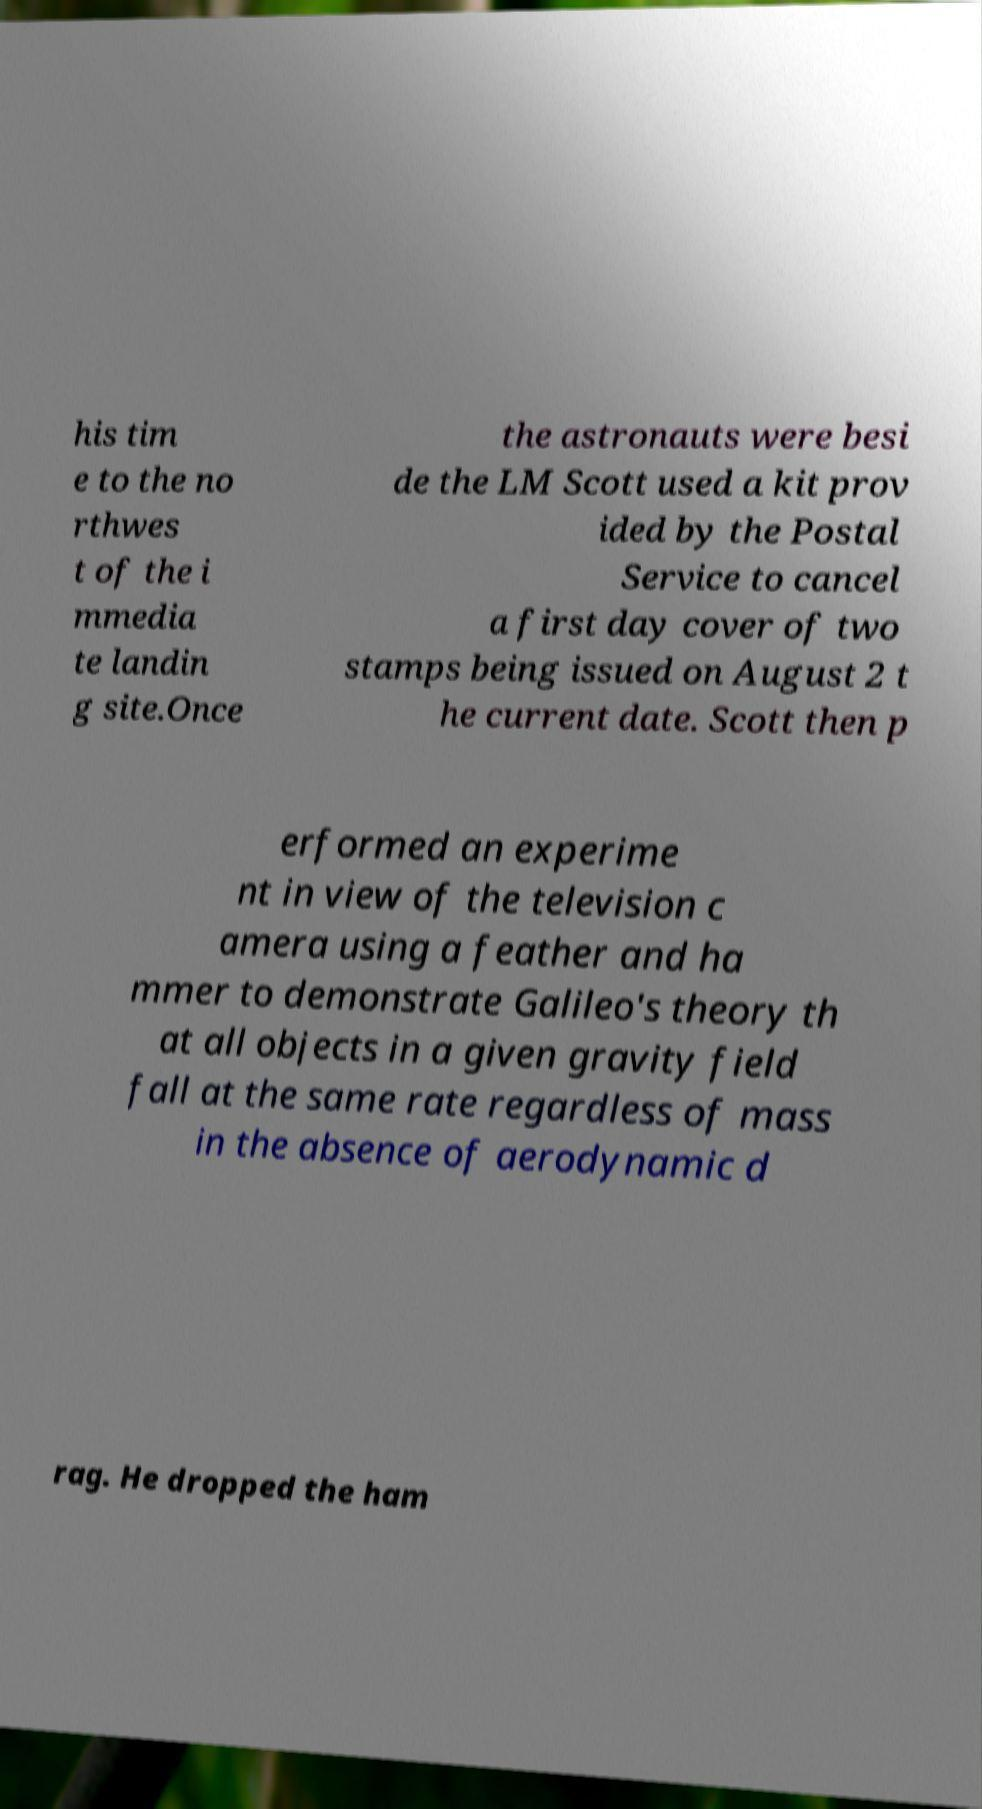Please read and relay the text visible in this image. What does it say? his tim e to the no rthwes t of the i mmedia te landin g site.Once the astronauts were besi de the LM Scott used a kit prov ided by the Postal Service to cancel a first day cover of two stamps being issued on August 2 t he current date. Scott then p erformed an experime nt in view of the television c amera using a feather and ha mmer to demonstrate Galileo's theory th at all objects in a given gravity field fall at the same rate regardless of mass in the absence of aerodynamic d rag. He dropped the ham 